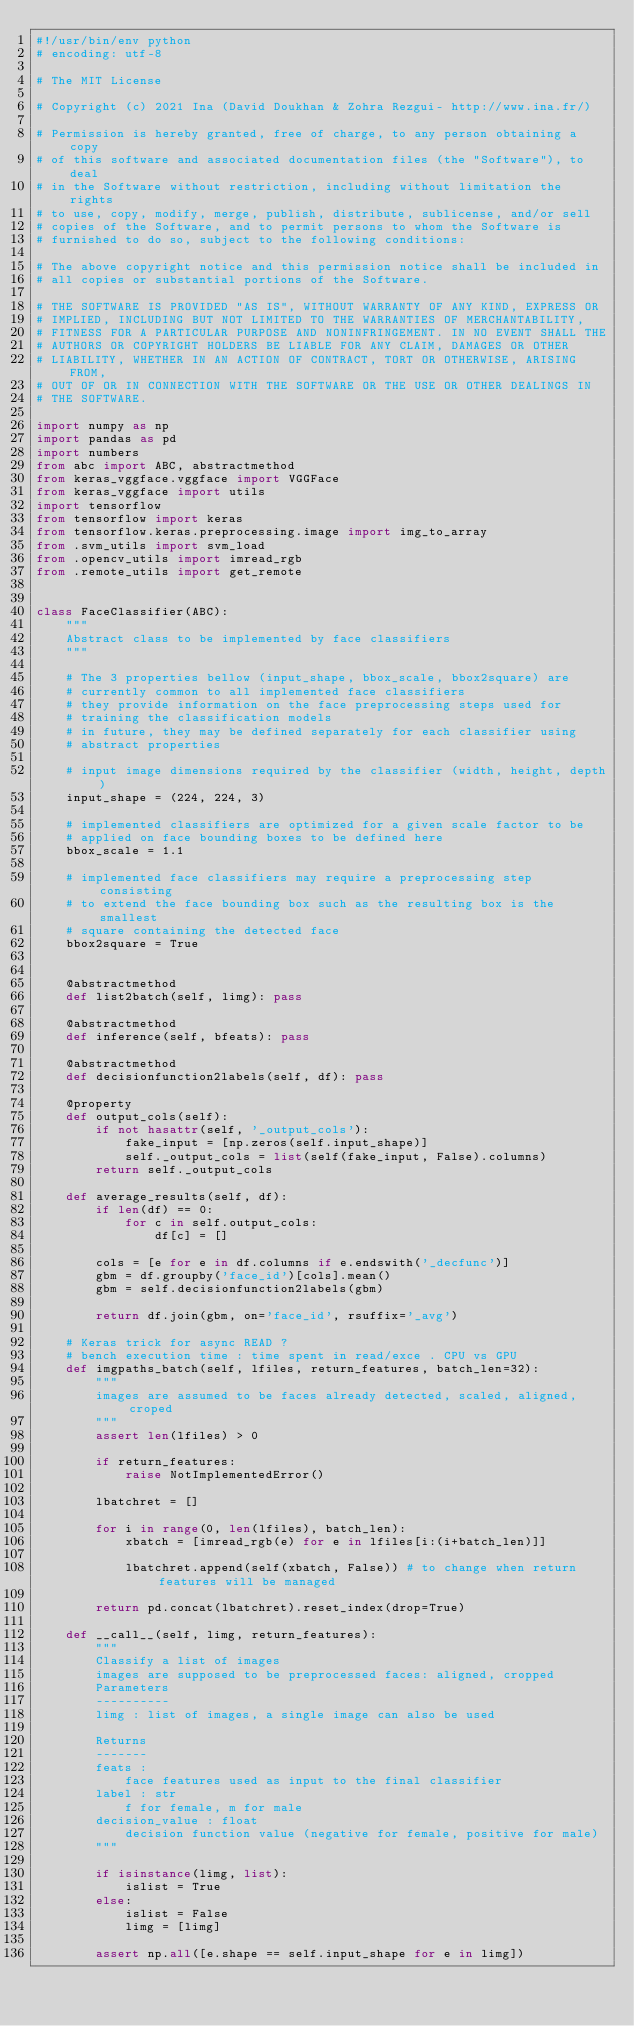Convert code to text. <code><loc_0><loc_0><loc_500><loc_500><_Python_>#!/usr/bin/env python
# encoding: utf-8

# The MIT License

# Copyright (c) 2021 Ina (David Doukhan & Zohra Rezgui- http://www.ina.fr/)

# Permission is hereby granted, free of charge, to any person obtaining a copy
# of this software and associated documentation files (the "Software"), to deal
# in the Software without restriction, including without limitation the rights
# to use, copy, modify, merge, publish, distribute, sublicense, and/or sell
# copies of the Software, and to permit persons to whom the Software is
# furnished to do so, subject to the following conditions:

# The above copyright notice and this permission notice shall be included in
# all copies or substantial portions of the Software.

# THE SOFTWARE IS PROVIDED "AS IS", WITHOUT WARRANTY OF ANY KIND, EXPRESS OR
# IMPLIED, INCLUDING BUT NOT LIMITED TO THE WARRANTIES OF MERCHANTABILITY,
# FITNESS FOR A PARTICULAR PURPOSE AND NONINFRINGEMENT. IN NO EVENT SHALL THE
# AUTHORS OR COPYRIGHT HOLDERS BE LIABLE FOR ANY CLAIM, DAMAGES OR OTHER
# LIABILITY, WHETHER IN AN ACTION OF CONTRACT, TORT OR OTHERWISE, ARISING FROM,
# OUT OF OR IN CONNECTION WITH THE SOFTWARE OR THE USE OR OTHER DEALINGS IN
# THE SOFTWARE.

import numpy as np
import pandas as pd
import numbers
from abc import ABC, abstractmethod
from keras_vggface.vggface import VGGFace
from keras_vggface import utils
import tensorflow
from tensorflow import keras
from tensorflow.keras.preprocessing.image import img_to_array
from .svm_utils import svm_load
from .opencv_utils import imread_rgb
from .remote_utils import get_remote


class FaceClassifier(ABC):
    """
    Abstract class to be implemented by face classifiers
    """

    # The 3 properties bellow (input_shape, bbox_scale, bbox2square) are
    # currently common to all implemented face classifiers
    # they provide information on the face preprocessing steps used for
    # training the classification models
    # in future, they may be defined separately for each classifier using
    # abstract properties

    # input image dimensions required by the classifier (width, height, depth)
    input_shape = (224, 224, 3)

    # implemented classifiers are optimized for a given scale factor to be
    # applied on face bounding boxes to be defined here
    bbox_scale = 1.1

    # implemented face classifiers may require a preprocessing step consisting
    # to extend the face bounding box such as the resulting box is the smallest
    # square containing the detected face
    bbox2square = True


    @abstractmethod
    def list2batch(self, limg): pass

    @abstractmethod
    def inference(self, bfeats): pass

    @abstractmethod
    def decisionfunction2labels(self, df): pass

    @property
    def output_cols(self):
        if not hasattr(self, '_output_cols'):
            fake_input = [np.zeros(self.input_shape)]
            self._output_cols = list(self(fake_input, False).columns)
        return self._output_cols

    def average_results(self, df):
        if len(df) == 0:
            for c in self.output_cols:
                df[c] = []

        cols = [e for e in df.columns if e.endswith('_decfunc')]
        gbm = df.groupby('face_id')[cols].mean()
        gbm = self.decisionfunction2labels(gbm)

        return df.join(gbm, on='face_id', rsuffix='_avg')

    # Keras trick for async READ ?
    # bench execution time : time spent in read/exce . CPU vs GPU
    def imgpaths_batch(self, lfiles, return_features, batch_len=32):
        """
        images are assumed to be faces already detected, scaled, aligned, croped
        """
        assert len(lfiles) > 0

        if return_features:
            raise NotImplementedError()

        lbatchret = []

        for i in range(0, len(lfiles), batch_len):
            xbatch = [imread_rgb(e) for e in lfiles[i:(i+batch_len)]]

            lbatchret.append(self(xbatch, False)) # to change when return features will be managed

        return pd.concat(lbatchret).reset_index(drop=True)

    def __call__(self, limg, return_features):
        """
        Classify a list of images
        images are supposed to be preprocessed faces: aligned, cropped
        Parameters
        ----------
        limg : list of images, a single image can also be used

        Returns
        -------
        feats :
            face features used as input to the final classifier
        label : str
            f for female, m for male
        decision_value : float
            decision function value (negative for female, positive for male)
        """

        if isinstance(limg, list):
            islist = True
        else:
            islist = False
            limg = [limg]

        assert np.all([e.shape == self.input_shape for e in limg])</code> 